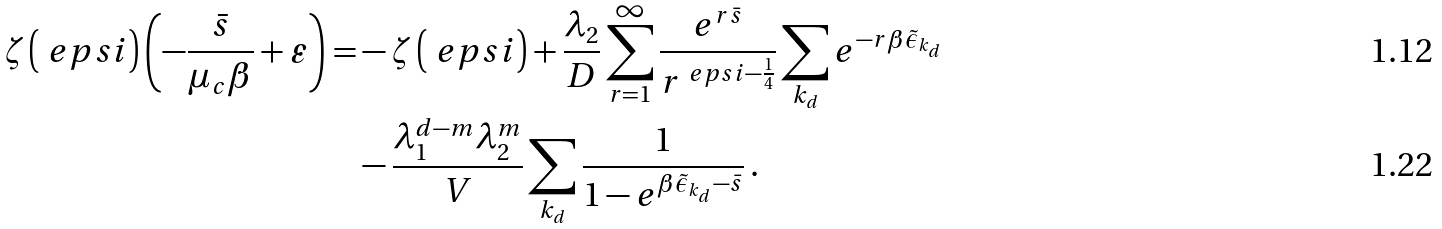<formula> <loc_0><loc_0><loc_500><loc_500>\zeta \left ( \ e p s i \right ) \left ( - \frac { \bar { s } } { \mu _ { c } \beta } + \varepsilon \right ) = & - \zeta \left ( \ e p s i \right ) + \frac { \lambda _ { 2 } } { D } \sum _ { r = 1 } ^ { \infty } \frac { e ^ { r \bar { s } } } { r ^ { \ e p s i - \frac { 1 } { 4 } } } \sum _ { k _ { d } } e ^ { - r \beta \tilde { \epsilon } _ { k _ { d } } } \\ & - \frac { \lambda _ { 1 } ^ { d - m } \lambda _ { 2 } ^ { m } } { V } \sum _ { k _ { d } } \frac { 1 } { 1 - e ^ { \beta \tilde { \epsilon } _ { k _ { d } } - \bar { s } } } \, .</formula> 